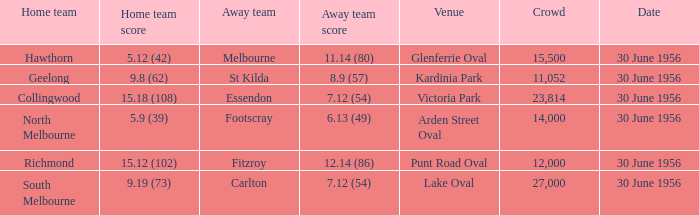12 (54) and in excess of 12,000 individuals? Collingwood. 